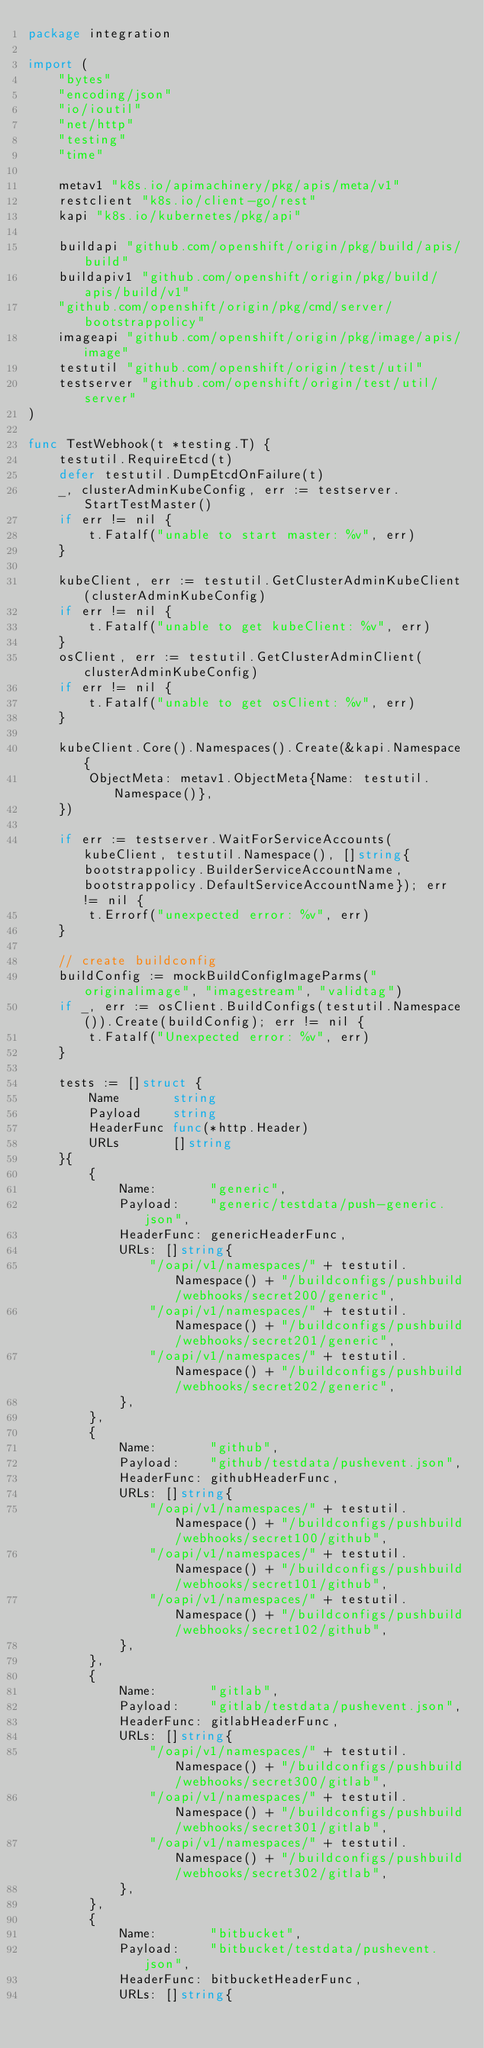<code> <loc_0><loc_0><loc_500><loc_500><_Go_>package integration

import (
	"bytes"
	"encoding/json"
	"io/ioutil"
	"net/http"
	"testing"
	"time"

	metav1 "k8s.io/apimachinery/pkg/apis/meta/v1"
	restclient "k8s.io/client-go/rest"
	kapi "k8s.io/kubernetes/pkg/api"

	buildapi "github.com/openshift/origin/pkg/build/apis/build"
	buildapiv1 "github.com/openshift/origin/pkg/build/apis/build/v1"
	"github.com/openshift/origin/pkg/cmd/server/bootstrappolicy"
	imageapi "github.com/openshift/origin/pkg/image/apis/image"
	testutil "github.com/openshift/origin/test/util"
	testserver "github.com/openshift/origin/test/util/server"
)

func TestWebhook(t *testing.T) {
	testutil.RequireEtcd(t)
	defer testutil.DumpEtcdOnFailure(t)
	_, clusterAdminKubeConfig, err := testserver.StartTestMaster()
	if err != nil {
		t.Fatalf("unable to start master: %v", err)
	}

	kubeClient, err := testutil.GetClusterAdminKubeClient(clusterAdminKubeConfig)
	if err != nil {
		t.Fatalf("unable to get kubeClient: %v", err)
	}
	osClient, err := testutil.GetClusterAdminClient(clusterAdminKubeConfig)
	if err != nil {
		t.Fatalf("unable to get osClient: %v", err)
	}

	kubeClient.Core().Namespaces().Create(&kapi.Namespace{
		ObjectMeta: metav1.ObjectMeta{Name: testutil.Namespace()},
	})

	if err := testserver.WaitForServiceAccounts(kubeClient, testutil.Namespace(), []string{bootstrappolicy.BuilderServiceAccountName, bootstrappolicy.DefaultServiceAccountName}); err != nil {
		t.Errorf("unexpected error: %v", err)
	}

	// create buildconfig
	buildConfig := mockBuildConfigImageParms("originalimage", "imagestream", "validtag")
	if _, err := osClient.BuildConfigs(testutil.Namespace()).Create(buildConfig); err != nil {
		t.Fatalf("Unexpected error: %v", err)
	}

	tests := []struct {
		Name       string
		Payload    string
		HeaderFunc func(*http.Header)
		URLs       []string
	}{
		{
			Name:       "generic",
			Payload:    "generic/testdata/push-generic.json",
			HeaderFunc: genericHeaderFunc,
			URLs: []string{
				"/oapi/v1/namespaces/" + testutil.Namespace() + "/buildconfigs/pushbuild/webhooks/secret200/generic",
				"/oapi/v1/namespaces/" + testutil.Namespace() + "/buildconfigs/pushbuild/webhooks/secret201/generic",
				"/oapi/v1/namespaces/" + testutil.Namespace() + "/buildconfigs/pushbuild/webhooks/secret202/generic",
			},
		},
		{
			Name:       "github",
			Payload:    "github/testdata/pushevent.json",
			HeaderFunc: githubHeaderFunc,
			URLs: []string{
				"/oapi/v1/namespaces/" + testutil.Namespace() + "/buildconfigs/pushbuild/webhooks/secret100/github",
				"/oapi/v1/namespaces/" + testutil.Namespace() + "/buildconfigs/pushbuild/webhooks/secret101/github",
				"/oapi/v1/namespaces/" + testutil.Namespace() + "/buildconfigs/pushbuild/webhooks/secret102/github",
			},
		},
		{
			Name:       "gitlab",
			Payload:    "gitlab/testdata/pushevent.json",
			HeaderFunc: gitlabHeaderFunc,
			URLs: []string{
				"/oapi/v1/namespaces/" + testutil.Namespace() + "/buildconfigs/pushbuild/webhooks/secret300/gitlab",
				"/oapi/v1/namespaces/" + testutil.Namespace() + "/buildconfigs/pushbuild/webhooks/secret301/gitlab",
				"/oapi/v1/namespaces/" + testutil.Namespace() + "/buildconfigs/pushbuild/webhooks/secret302/gitlab",
			},
		},
		{
			Name:       "bitbucket",
			Payload:    "bitbucket/testdata/pushevent.json",
			HeaderFunc: bitbucketHeaderFunc,
			URLs: []string{</code> 